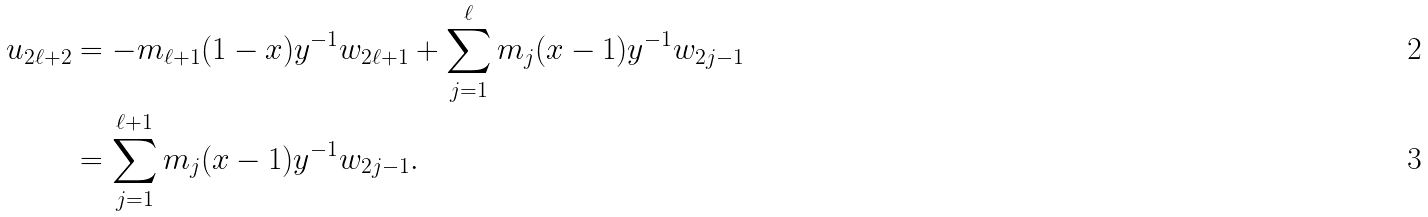<formula> <loc_0><loc_0><loc_500><loc_500>u _ { 2 \ell + 2 } & = - m _ { \ell + 1 } ( 1 - x ) y ^ { - 1 } w _ { 2 \ell + 1 } + \sum _ { j = 1 } ^ { \ell } m _ { j } ( x - 1 ) y ^ { - 1 } w _ { 2 j - 1 } \\ & = \sum _ { j = 1 } ^ { \ell + 1 } m _ { j } ( x - 1 ) y ^ { - 1 } w _ { 2 j - 1 } .</formula> 